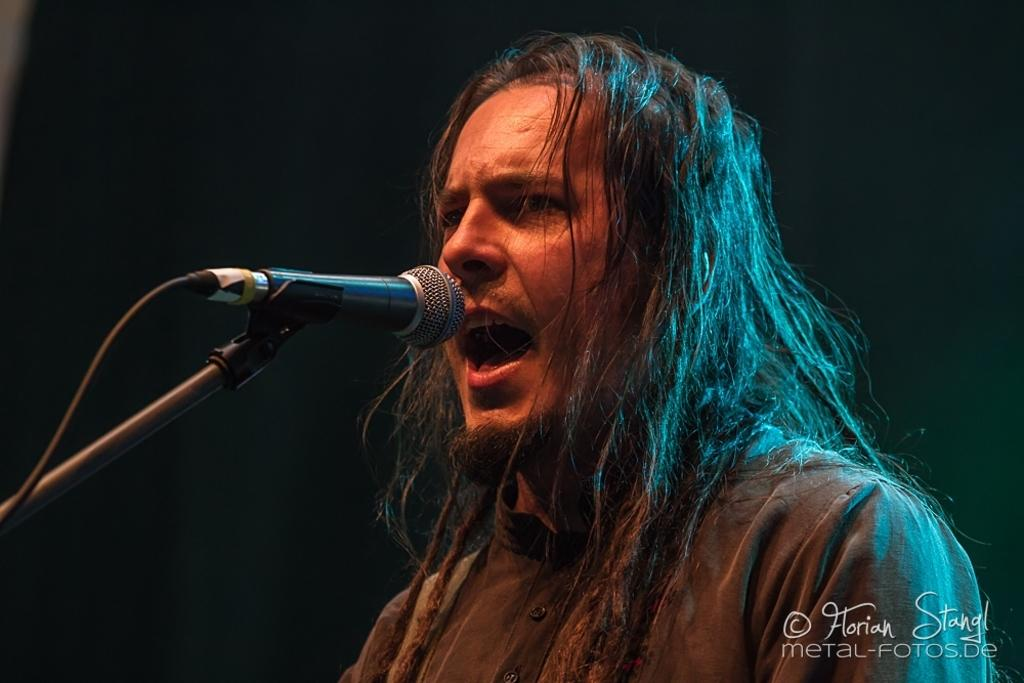Who or what is in the image? There is a person in the image. What is the person doing or interacting with in the image? The person is in front of a microphone. Are there any additional elements or features in the image? Yes, there is a watermark in the image, and some text is visible in the bottom right corner. How many tomatoes can be seen in the image? There are no tomatoes present in the image. What type of mist is visible around the person in the image? There is no mist visible in the image; the person is in front of a microphone. 